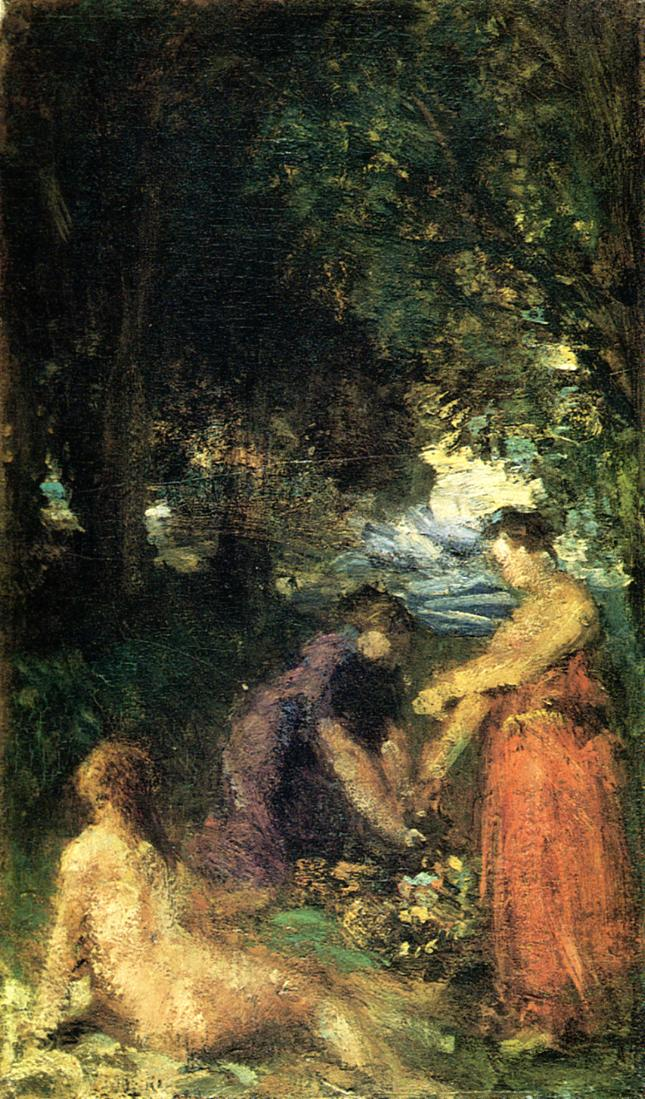Imagine the scene depicted in this painting as part of a story. What could be happening before and after this moment? Before this moment, the individuals depicted might have journeyed through the forest, enjoying the sights, sounds, and smells of nature. They could have taken a break at this particular spot to rest and share a meal. After this moment, they might continue their exploration, perhaps reaching a scenic viewpoint or heading back to their homes, enriched by the shared experience and the tranquility they found in nature. 